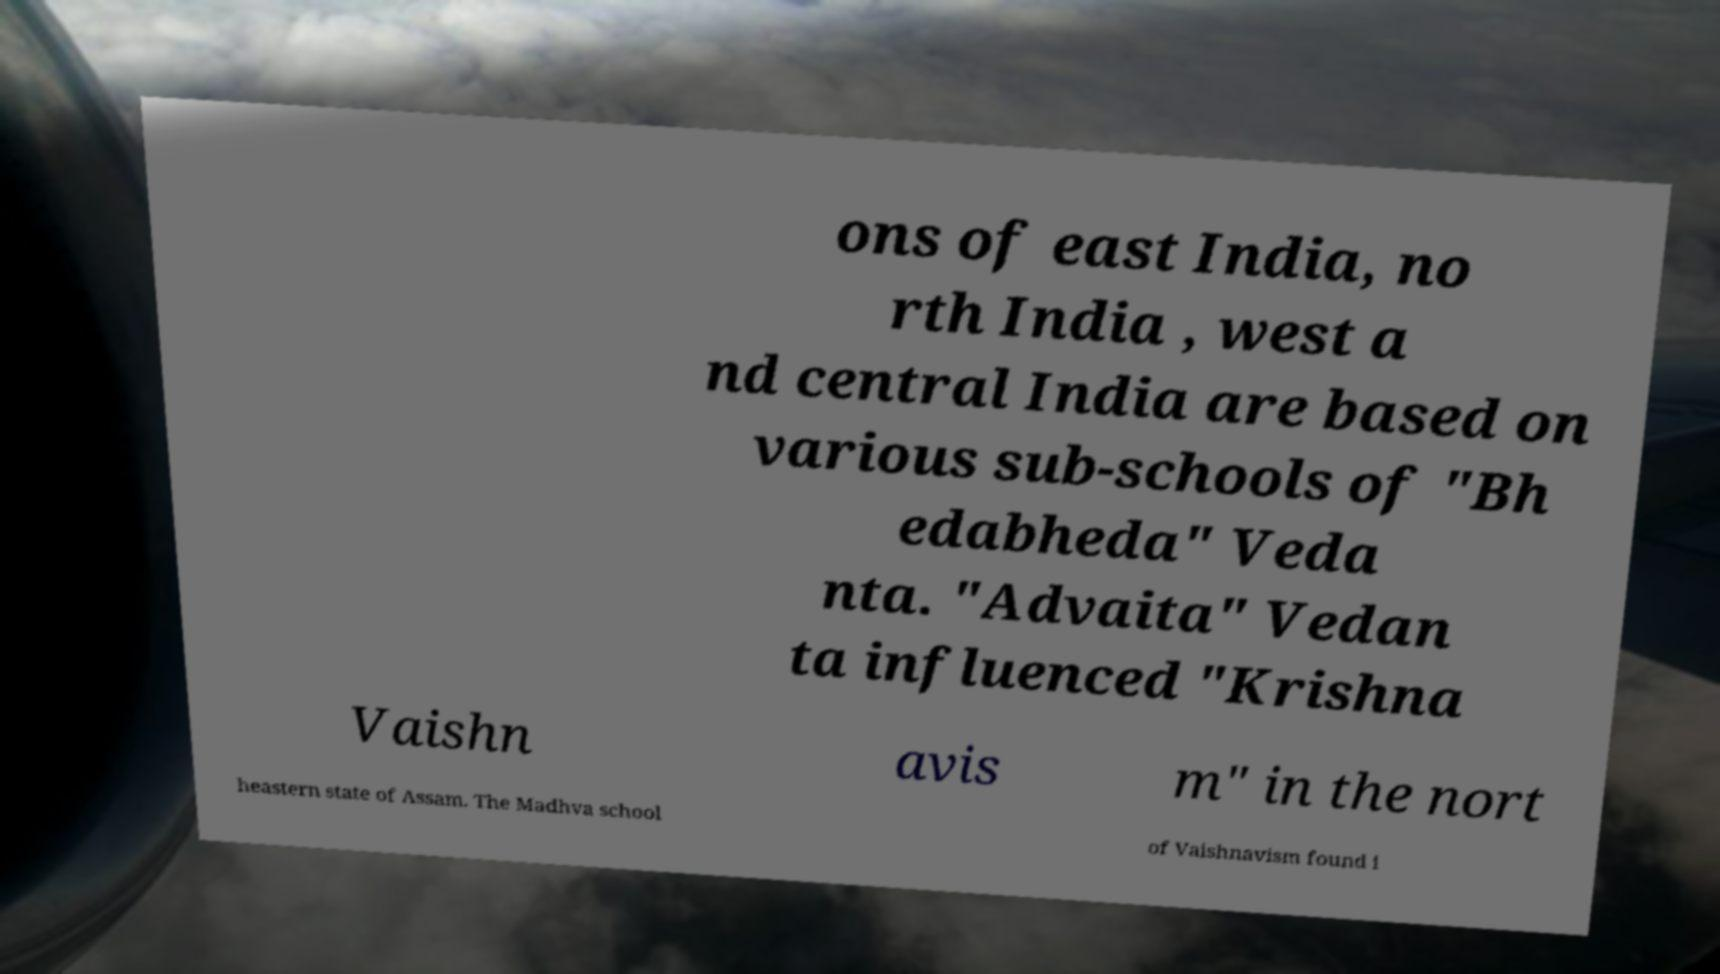Please read and relay the text visible in this image. What does it say? ons of east India, no rth India , west a nd central India are based on various sub-schools of "Bh edabheda" Veda nta. "Advaita" Vedan ta influenced "Krishna Vaishn avis m" in the nort heastern state of Assam. The Madhva school of Vaishnavism found i 